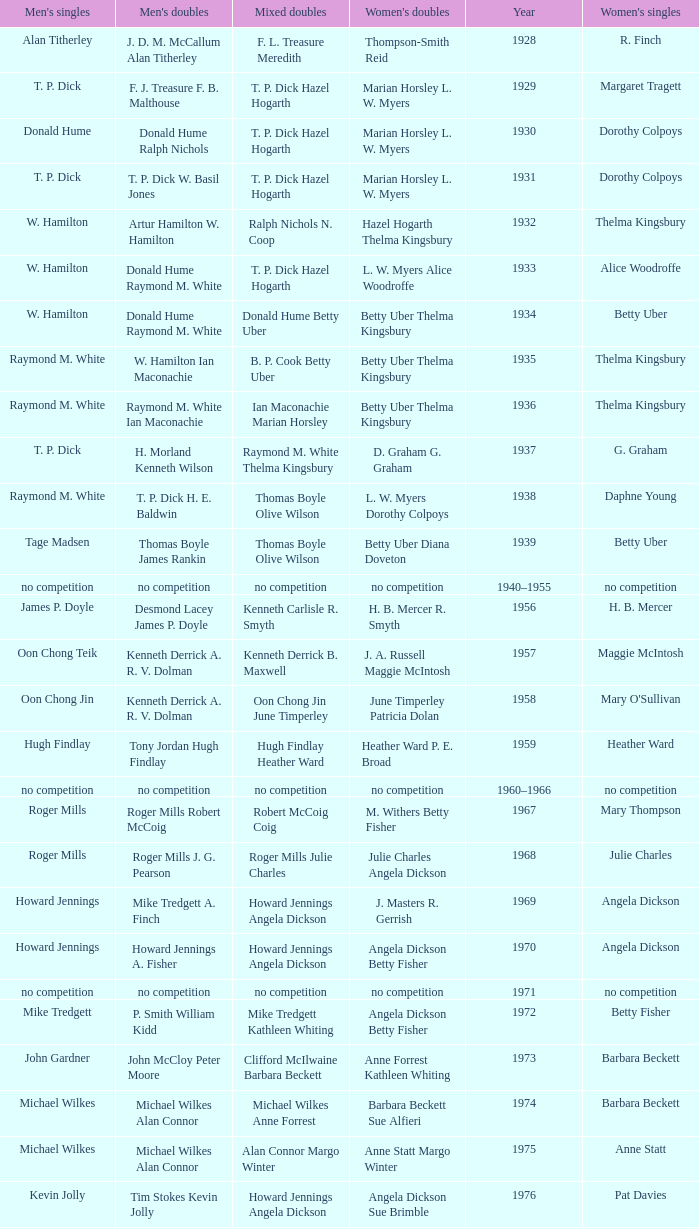Who won the Women's doubles in the year that Jesper Knudsen Nettie Nielsen won the Mixed doubles? Karen Beckman Sara Halsall. 